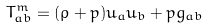Convert formula to latex. <formula><loc_0><loc_0><loc_500><loc_500>T _ { a b } ^ { m } = ( \rho + p ) u _ { a } u _ { b } + p g _ { a b }</formula> 